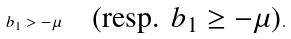<formula> <loc_0><loc_0><loc_500><loc_500>b _ { 1 } > - \mu \quad \text {(resp. $b_{1} \geq - \mu$)} .</formula> 